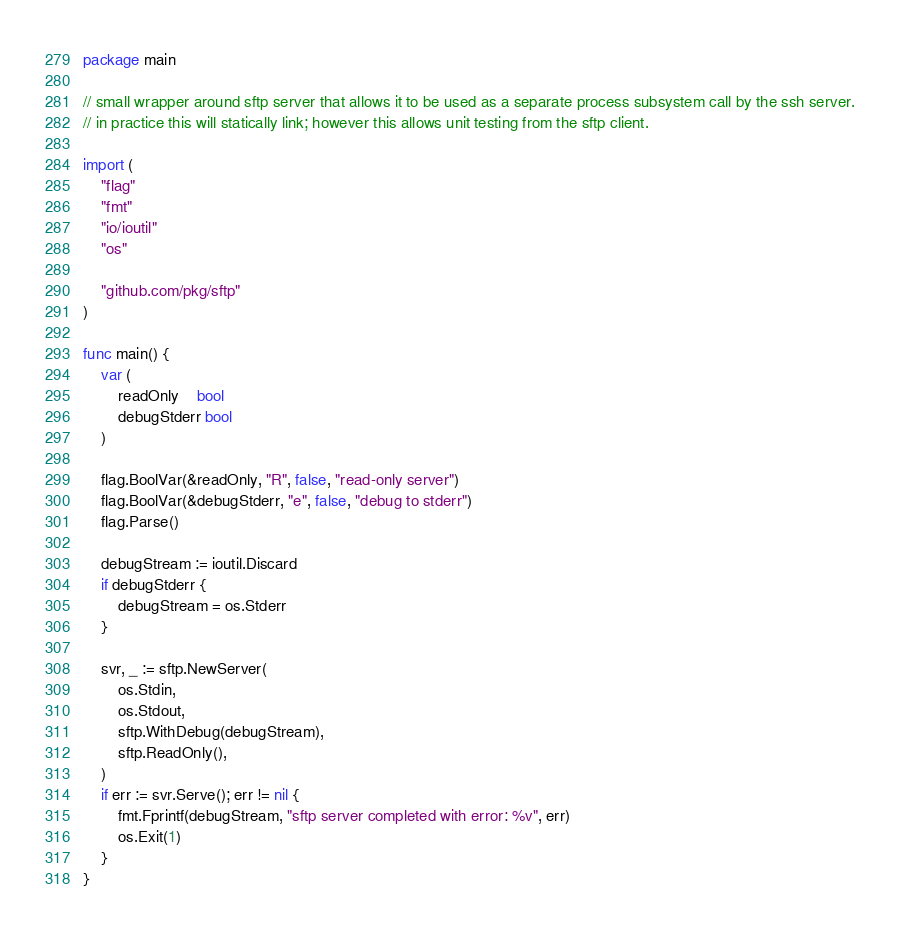Convert code to text. <code><loc_0><loc_0><loc_500><loc_500><_Go_>package main

// small wrapper around sftp server that allows it to be used as a separate process subsystem call by the ssh server.
// in practice this will statically link; however this allows unit testing from the sftp client.

import (
	"flag"
	"fmt"
	"io/ioutil"
	"os"

	"github.com/pkg/sftp"
)

func main() {
	var (
		readOnly    bool
		debugStderr bool
	)

	flag.BoolVar(&readOnly, "R", false, "read-only server")
	flag.BoolVar(&debugStderr, "e", false, "debug to stderr")
	flag.Parse()

	debugStream := ioutil.Discard
	if debugStderr {
		debugStream = os.Stderr
	}

	svr, _ := sftp.NewServer(
		os.Stdin,
		os.Stdout,
		sftp.WithDebug(debugStream),
		sftp.ReadOnly(),
	)
	if err := svr.Serve(); err != nil {
		fmt.Fprintf(debugStream, "sftp server completed with error: %v", err)
		os.Exit(1)
	}
}
</code> 